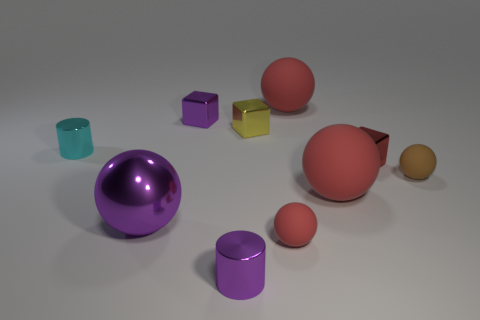Which object looks closest to the viewpoint? From the given perspective, the large purple sphere appears to be the closest object to the viewpoint. It's positioned in the foreground and has a significant visual prominence relative to the other elements. 